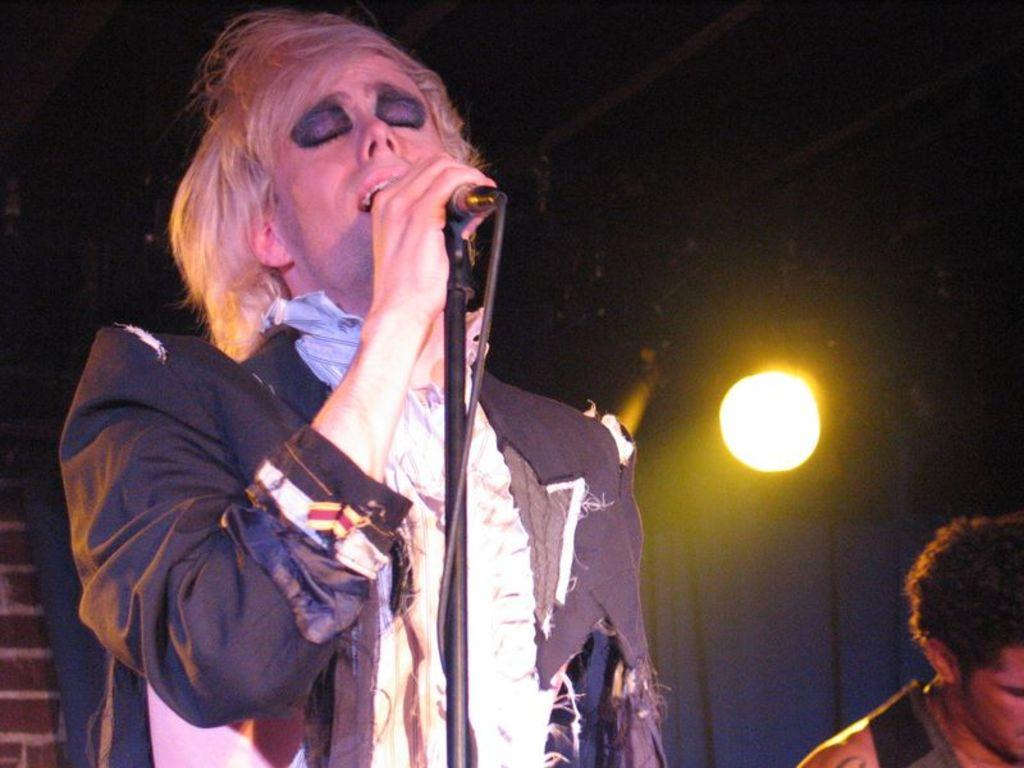What is the man in the image doing? The man is singing in the image. What is the man holding while singing? The man is holding a microphone. Is there anyone else present in the image? Yes, there is another man beside the singer. What can be seen in the background of the image? There is light, a curtain, and a wall in the background of the image. How would you describe the overall lighting in the image? The image appears to be dark. What type of picture is hanging on the wall in the image? There is no picture hanging on the wall in the image; only a curtain and a wall are visible in the background. What does the man need to continue singing in the image? The man does not need anything to continue singing in the image, as he is already holding a microphone. 